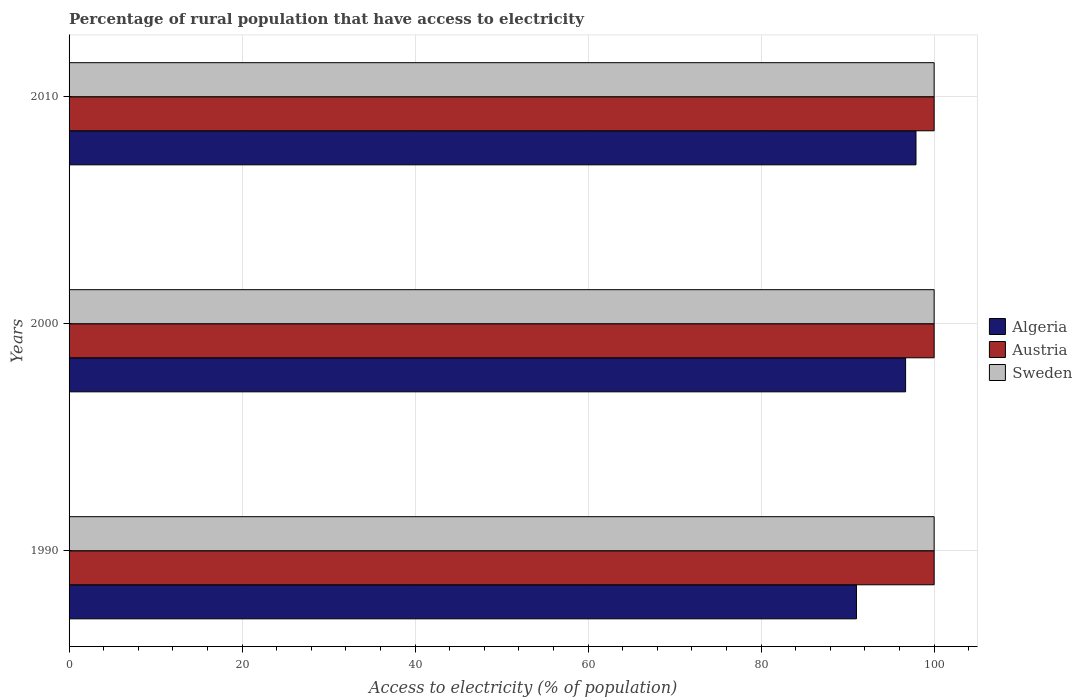How many different coloured bars are there?
Provide a short and direct response. 3. How many groups of bars are there?
Your answer should be very brief. 3. How many bars are there on the 3rd tick from the bottom?
Your answer should be very brief. 3. What is the percentage of rural population that have access to electricity in Sweden in 2010?
Your answer should be very brief. 100. Across all years, what is the maximum percentage of rural population that have access to electricity in Sweden?
Your response must be concise. 100. Across all years, what is the minimum percentage of rural population that have access to electricity in Sweden?
Your answer should be compact. 100. What is the total percentage of rural population that have access to electricity in Algeria in the graph?
Your answer should be compact. 285.62. What is the difference between the percentage of rural population that have access to electricity in Austria in 1990 and that in 2000?
Your response must be concise. 0. What is the difference between the percentage of rural population that have access to electricity in Austria in 1990 and the percentage of rural population that have access to electricity in Algeria in 2000?
Your answer should be compact. 3.3. In the year 2000, what is the difference between the percentage of rural population that have access to electricity in Algeria and percentage of rural population that have access to electricity in Sweden?
Your answer should be compact. -3.3. In how many years, is the percentage of rural population that have access to electricity in Austria greater than 44 %?
Provide a short and direct response. 3. What is the ratio of the percentage of rural population that have access to electricity in Algeria in 1990 to that in 2010?
Make the answer very short. 0.93. Is the difference between the percentage of rural population that have access to electricity in Algeria in 1990 and 2010 greater than the difference between the percentage of rural population that have access to electricity in Sweden in 1990 and 2010?
Make the answer very short. No. What is the difference between the highest and the second highest percentage of rural population that have access to electricity in Algeria?
Your response must be concise. 1.2. What is the difference between the highest and the lowest percentage of rural population that have access to electricity in Algeria?
Offer a terse response. 6.88. Is the sum of the percentage of rural population that have access to electricity in Algeria in 1990 and 2010 greater than the maximum percentage of rural population that have access to electricity in Sweden across all years?
Give a very brief answer. Yes. What does the 1st bar from the bottom in 2010 represents?
Give a very brief answer. Algeria. Is it the case that in every year, the sum of the percentage of rural population that have access to electricity in Algeria and percentage of rural population that have access to electricity in Sweden is greater than the percentage of rural population that have access to electricity in Austria?
Your answer should be compact. Yes. How many bars are there?
Your answer should be very brief. 9. Are all the bars in the graph horizontal?
Your response must be concise. Yes. Does the graph contain grids?
Offer a terse response. Yes. How are the legend labels stacked?
Provide a short and direct response. Vertical. What is the title of the graph?
Make the answer very short. Percentage of rural population that have access to electricity. What is the label or title of the X-axis?
Your answer should be compact. Access to electricity (% of population). What is the Access to electricity (% of population) in Algeria in 1990?
Your answer should be very brief. 91.02. What is the Access to electricity (% of population) in Austria in 1990?
Keep it short and to the point. 100. What is the Access to electricity (% of population) in Algeria in 2000?
Make the answer very short. 96.7. What is the Access to electricity (% of population) of Austria in 2000?
Provide a succinct answer. 100. What is the Access to electricity (% of population) in Algeria in 2010?
Give a very brief answer. 97.9. What is the Access to electricity (% of population) in Austria in 2010?
Your answer should be compact. 100. Across all years, what is the maximum Access to electricity (% of population) in Algeria?
Your answer should be very brief. 97.9. Across all years, what is the maximum Access to electricity (% of population) in Sweden?
Your answer should be compact. 100. Across all years, what is the minimum Access to electricity (% of population) of Algeria?
Ensure brevity in your answer.  91.02. Across all years, what is the minimum Access to electricity (% of population) in Sweden?
Your response must be concise. 100. What is the total Access to electricity (% of population) of Algeria in the graph?
Provide a succinct answer. 285.62. What is the total Access to electricity (% of population) in Austria in the graph?
Offer a terse response. 300. What is the total Access to electricity (% of population) in Sweden in the graph?
Offer a very short reply. 300. What is the difference between the Access to electricity (% of population) in Algeria in 1990 and that in 2000?
Your response must be concise. -5.68. What is the difference between the Access to electricity (% of population) in Austria in 1990 and that in 2000?
Offer a very short reply. 0. What is the difference between the Access to electricity (% of population) of Algeria in 1990 and that in 2010?
Your answer should be compact. -6.88. What is the difference between the Access to electricity (% of population) in Algeria in 2000 and that in 2010?
Provide a short and direct response. -1.2. What is the difference between the Access to electricity (% of population) of Austria in 2000 and that in 2010?
Provide a succinct answer. 0. What is the difference between the Access to electricity (% of population) of Sweden in 2000 and that in 2010?
Ensure brevity in your answer.  0. What is the difference between the Access to electricity (% of population) of Algeria in 1990 and the Access to electricity (% of population) of Austria in 2000?
Provide a succinct answer. -8.98. What is the difference between the Access to electricity (% of population) of Algeria in 1990 and the Access to electricity (% of population) of Sweden in 2000?
Give a very brief answer. -8.98. What is the difference between the Access to electricity (% of population) of Austria in 1990 and the Access to electricity (% of population) of Sweden in 2000?
Your answer should be compact. 0. What is the difference between the Access to electricity (% of population) in Algeria in 1990 and the Access to electricity (% of population) in Austria in 2010?
Your answer should be very brief. -8.98. What is the difference between the Access to electricity (% of population) in Algeria in 1990 and the Access to electricity (% of population) in Sweden in 2010?
Offer a very short reply. -8.98. What is the difference between the Access to electricity (% of population) in Algeria in 2000 and the Access to electricity (% of population) in Austria in 2010?
Provide a short and direct response. -3.3. What is the difference between the Access to electricity (% of population) in Algeria in 2000 and the Access to electricity (% of population) in Sweden in 2010?
Keep it short and to the point. -3.3. What is the difference between the Access to electricity (% of population) of Austria in 2000 and the Access to electricity (% of population) of Sweden in 2010?
Offer a terse response. 0. What is the average Access to electricity (% of population) of Algeria per year?
Provide a succinct answer. 95.21. What is the average Access to electricity (% of population) in Austria per year?
Keep it short and to the point. 100. What is the average Access to electricity (% of population) of Sweden per year?
Provide a short and direct response. 100. In the year 1990, what is the difference between the Access to electricity (% of population) of Algeria and Access to electricity (% of population) of Austria?
Ensure brevity in your answer.  -8.98. In the year 1990, what is the difference between the Access to electricity (% of population) in Algeria and Access to electricity (% of population) in Sweden?
Provide a short and direct response. -8.98. In the year 2000, what is the difference between the Access to electricity (% of population) of Algeria and Access to electricity (% of population) of Austria?
Provide a short and direct response. -3.3. In the year 2000, what is the difference between the Access to electricity (% of population) of Austria and Access to electricity (% of population) of Sweden?
Provide a short and direct response. 0. In the year 2010, what is the difference between the Access to electricity (% of population) in Algeria and Access to electricity (% of population) in Sweden?
Your answer should be very brief. -2.1. In the year 2010, what is the difference between the Access to electricity (% of population) of Austria and Access to electricity (% of population) of Sweden?
Your response must be concise. 0. What is the ratio of the Access to electricity (% of population) of Algeria in 1990 to that in 2000?
Your answer should be compact. 0.94. What is the ratio of the Access to electricity (% of population) of Austria in 1990 to that in 2000?
Ensure brevity in your answer.  1. What is the ratio of the Access to electricity (% of population) of Algeria in 1990 to that in 2010?
Your response must be concise. 0.93. What is the ratio of the Access to electricity (% of population) in Austria in 1990 to that in 2010?
Provide a short and direct response. 1. What is the ratio of the Access to electricity (% of population) of Algeria in 2000 to that in 2010?
Offer a terse response. 0.99. What is the ratio of the Access to electricity (% of population) in Austria in 2000 to that in 2010?
Keep it short and to the point. 1. What is the ratio of the Access to electricity (% of population) in Sweden in 2000 to that in 2010?
Your response must be concise. 1. What is the difference between the highest and the second highest Access to electricity (% of population) of Austria?
Provide a succinct answer. 0. What is the difference between the highest and the second highest Access to electricity (% of population) in Sweden?
Give a very brief answer. 0. What is the difference between the highest and the lowest Access to electricity (% of population) of Algeria?
Offer a very short reply. 6.88. 